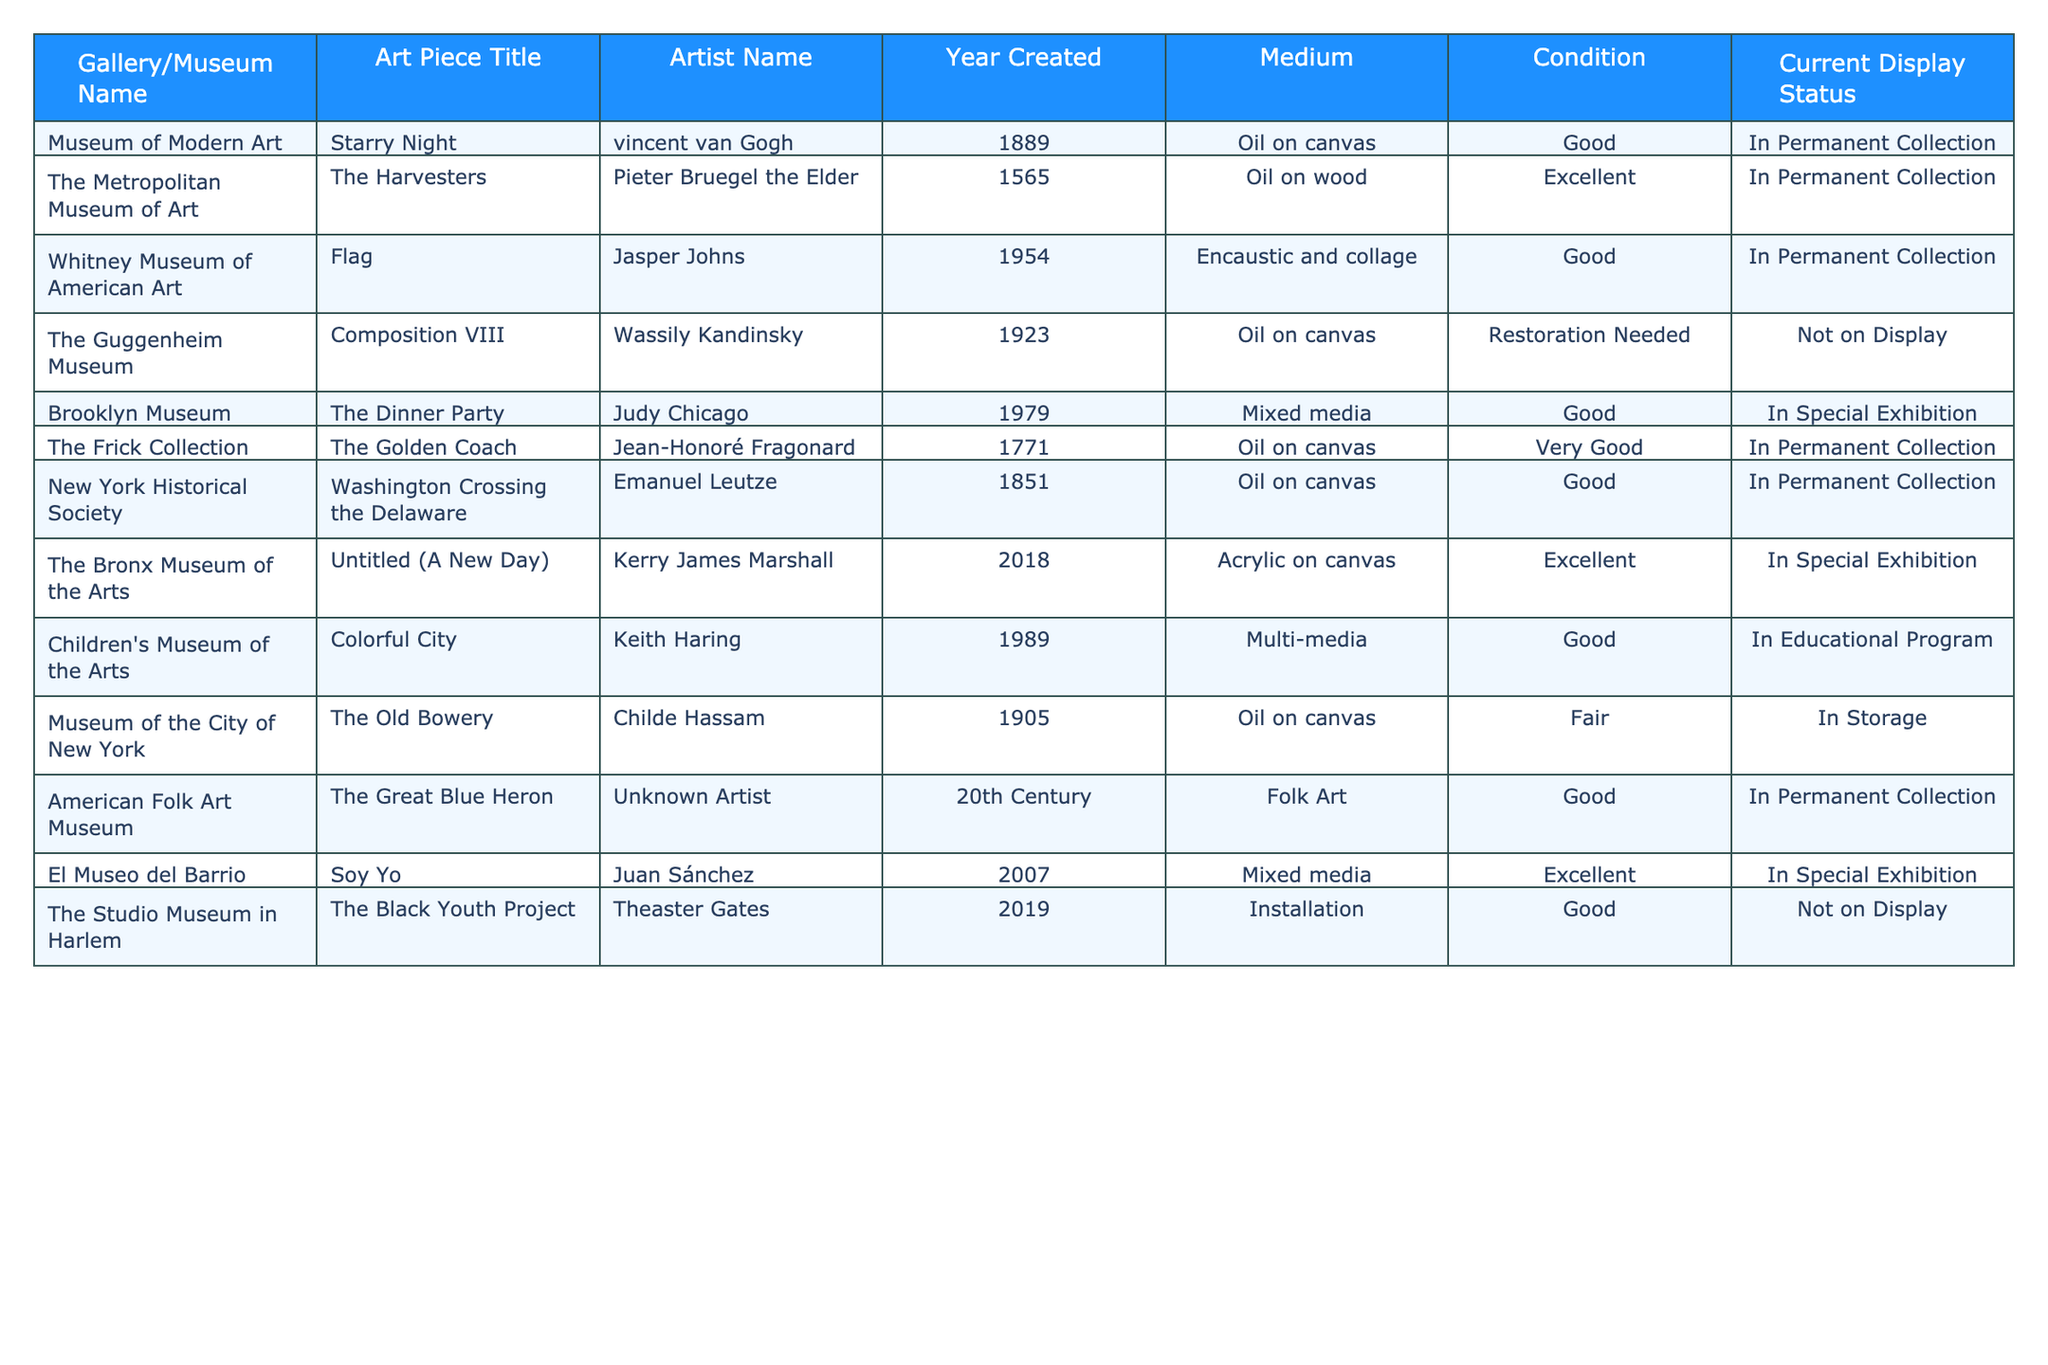What is the title of the art piece created by Vincent van Gogh? The table lists Vincent van Gogh as the artist for "Starry Night." Therefore, the title of the art piece created by him is "Starry Night."
Answer: Starry Night How many art pieces are currently in special exhibitions? The table shows two art pieces listed under special exhibitions: "The Dinner Party" and "Soy Yo." Therefore, there are two art pieces currently in special exhibitions.
Answer: 2 Which art piece is in fair condition and where is it located? The table indicates that "The Old Bowery" is in fair condition and is located at the Museum of the City of New York.
Answer: The Old Bowery, Museum of the City of New York Is there any artwork from the 18th century in the inventory? The table lists "The Golden Coach" by Jean-Honoré Fragonard from 1771, confirming that there is artwork from the 18th century in the inventory.
Answer: Yes What is the total number of art pieces displayed in the permanent collection? There are seven art pieces in the table with a display status of “In Permanent Collection.” These are: "Starry Night," "The Harvesters," "Flag," "The Golden Coach," "Washington Crossing the Delaware," "The Great Blue Heron," and "Untitled (A New Day)."
Answer: 7 How many artists have works displayed in the table, and who are they? The table features artworks from ten different artists: Vincent van Gogh, Pieter Bruegel the Elder, Jasper Johns, Wassily Kandinsky, Judy Chicago, Jean-Honoré Fragonard, Emanuel Leutze, Kerry James Marshall, Keith Haring, Juan Sánchez, and Theaster Gates.
Answer: 10 artists Which medium is most commonly used among the displayed artworks? By examining the medium column in the table, Oil on canvas appears three times, followed by other mediums like Mixed media, Acrylic on canvas, and Encaustic. Therefore, Oil on canvas is the most commonly used medium in the inventory.
Answer: Oil on canvas Are there any art pieces not currently on display? If so, how many? The table lists three artworks that are not currently on display: "Composition VIII," "The Black Youth Project," and "The Old Bowery." Therefore, there are three art pieces not currently on display.
Answer: 3 What is the average year created of the artworks in the inventory? The years of the artworks collected are: 1889, 1565, 1954, 1923, 1979, 1771, 1851, 2018, 1989, 1905, 20th Century, and 2007. Ignoring "20th Century," the sum is 1889 + 1565 + 1954 + 1923 + 1979 + 1771 + 1851 + 2018 + 1989 + 1905 + 2007 = 19949. Dividing by 11 gives the average year created as approximately 1814.82.
Answer: 1814.82 